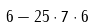Convert formula to latex. <formula><loc_0><loc_0><loc_500><loc_500>6 - 2 5 \cdot 7 \cdot 6</formula> 